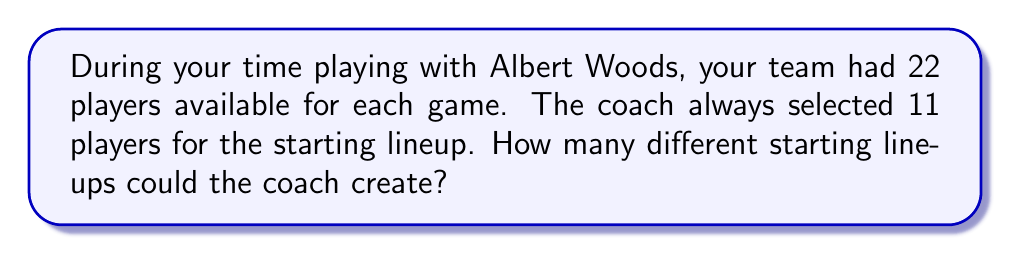Give your solution to this math problem. To solve this problem, we need to use the concept of combinations. Here's the step-by-step solution:

1) This is a combination problem because the order of selection doesn't matter (it's just about who's in the lineup, not their specific positions).

2) We are selecting 11 players out of 22 total players.

3) The formula for combinations is:

   $$C(n,r) = \frac{n!}{r!(n-r)!}$$

   where $n$ is the total number of items to choose from, and $r$ is the number of items being chosen.

4) In this case, $n = 22$ and $r = 11$

5) Plugging these values into our formula:

   $$C(22,11) = \frac{22!}{11!(22-11)!} = \frac{22!}{11!11!}$$

6) Expanding this:
   
   $$\frac{22 * 21 * 20 * 19 * 18 * 17 * 16 * 15 * 14 * 13 * 12 * 11!}{11! * 11 * 10 * 9 * 8 * 7 * 6 * 5 * 4 * 3 * 2 * 1}$$

7) The 11! cancels out in the numerator and denominator:

   $$\frac{22 * 21 * 20 * 19 * 18 * 17 * 16 * 15 * 14 * 13 * 12}{11 * 10 * 9 * 8 * 7 * 6 * 5 * 4 * 3 * 2 * 1}$$

8) Calculating this gives us 705,432.
Answer: 705,432 